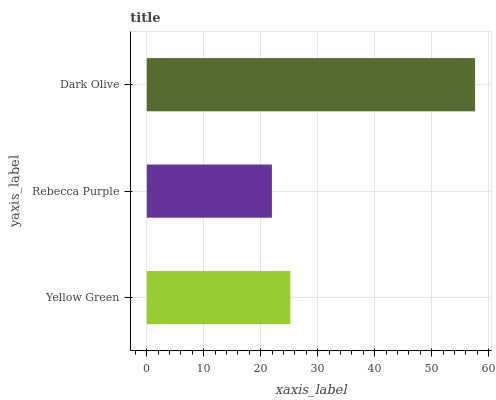Is Rebecca Purple the minimum?
Answer yes or no. Yes. Is Dark Olive the maximum?
Answer yes or no. Yes. Is Dark Olive the minimum?
Answer yes or no. No. Is Rebecca Purple the maximum?
Answer yes or no. No. Is Dark Olive greater than Rebecca Purple?
Answer yes or no. Yes. Is Rebecca Purple less than Dark Olive?
Answer yes or no. Yes. Is Rebecca Purple greater than Dark Olive?
Answer yes or no. No. Is Dark Olive less than Rebecca Purple?
Answer yes or no. No. Is Yellow Green the high median?
Answer yes or no. Yes. Is Yellow Green the low median?
Answer yes or no. Yes. Is Dark Olive the high median?
Answer yes or no. No. Is Dark Olive the low median?
Answer yes or no. No. 